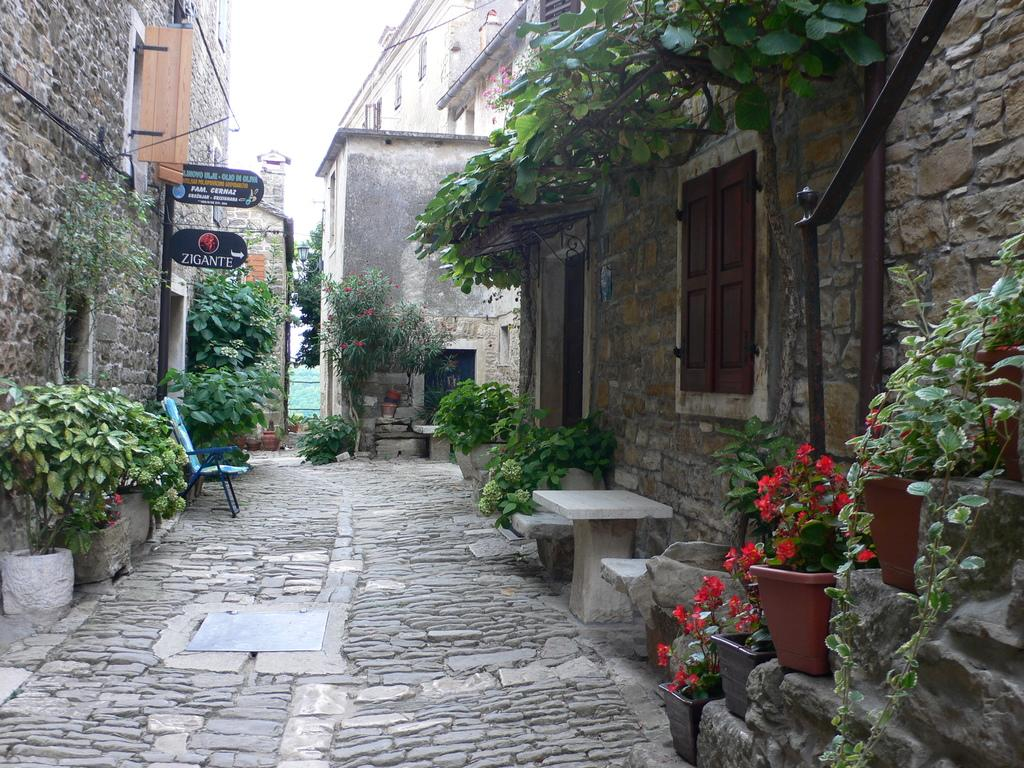What can be seen in the background of the image? The sky is visible in the image. What type of structures are present in the image? There are buildings in the image. What objects are present in the image that might be used for displaying information or advertisements? There are boards in the image. What type of furniture is present in the image? There is a chair in the image. What type of object is present in the image that might be used for growing plants? There is a planter in the image. What type of objects are present in the image that might be used for holding or storing items? There are pots in the image. What type of openings are present in the buildings in the image? There are windows in the image. What other unspecified objects are present in the image? There are unspecified objects in the image. What type of poison is being used to increase the profit of the business in the image? There is no mention of poison or profit in the image, and therefore it cannot be determined if any such activity is taking place. 